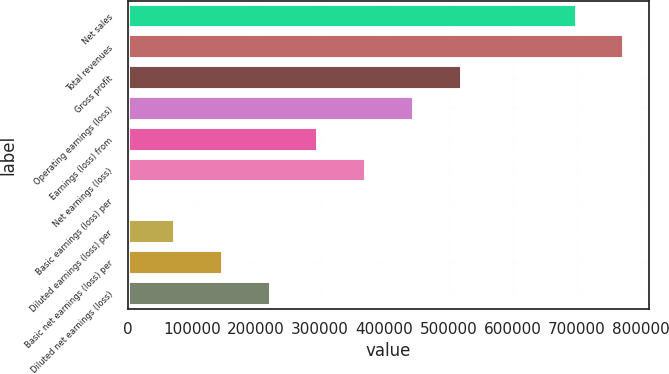<chart> <loc_0><loc_0><loc_500><loc_500><bar_chart><fcel>Net sales<fcel>Total revenues<fcel>Gross profit<fcel>Operating earnings (loss)<fcel>Earnings (loss) from<fcel>Net earnings (loss)<fcel>Basic earnings (loss) per<fcel>Diluted earnings (loss) per<fcel>Basic net earnings (loss) per<fcel>Diluted net earnings (loss)<nl><fcel>699792<fcel>774112<fcel>520243<fcel>445922<fcel>297282<fcel>371602<fcel>0.08<fcel>74320.5<fcel>148641<fcel>222961<nl></chart> 